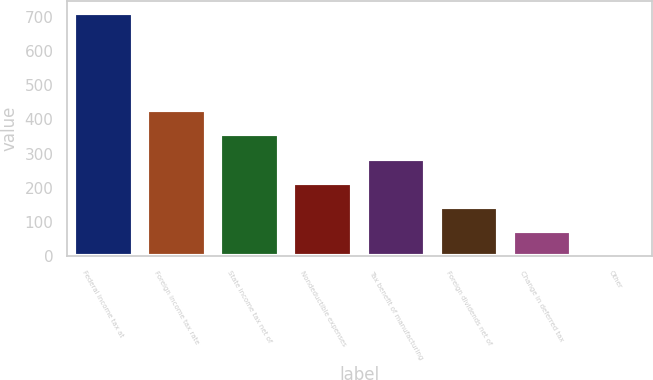<chart> <loc_0><loc_0><loc_500><loc_500><bar_chart><fcel>Federal income tax at<fcel>Foreign income tax rate<fcel>State income tax net of<fcel>Nondeductible expenses<fcel>Tax benefit of manufacturing<fcel>Foreign dividends net of<fcel>Change in deferred tax<fcel>Other<nl><fcel>710.1<fcel>426.86<fcel>356.05<fcel>214.43<fcel>285.24<fcel>143.62<fcel>72.81<fcel>2<nl></chart> 